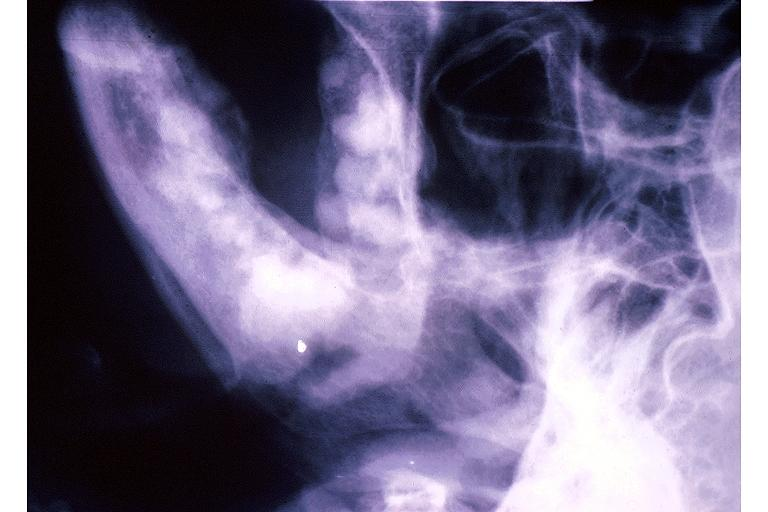what is present?
Answer the question using a single word or phrase. Oral 